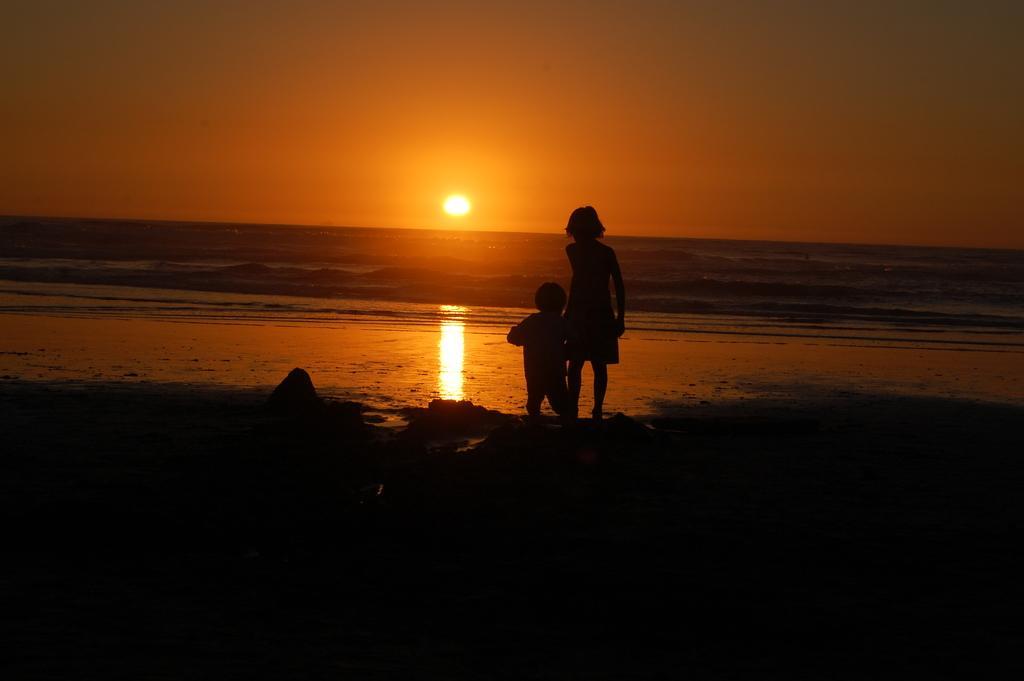In one or two sentences, can you explain what this image depicts? In the foreground of the picture we can see a girl, kid and mud. In the middle it looks like there is a water body. In the background we can see sun shining in the sky. 